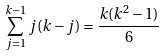<formula> <loc_0><loc_0><loc_500><loc_500>\sum _ { j = 1 } ^ { k - 1 } j ( k - j ) = \frac { k ( k ^ { 2 } - 1 ) } { 6 }</formula> 